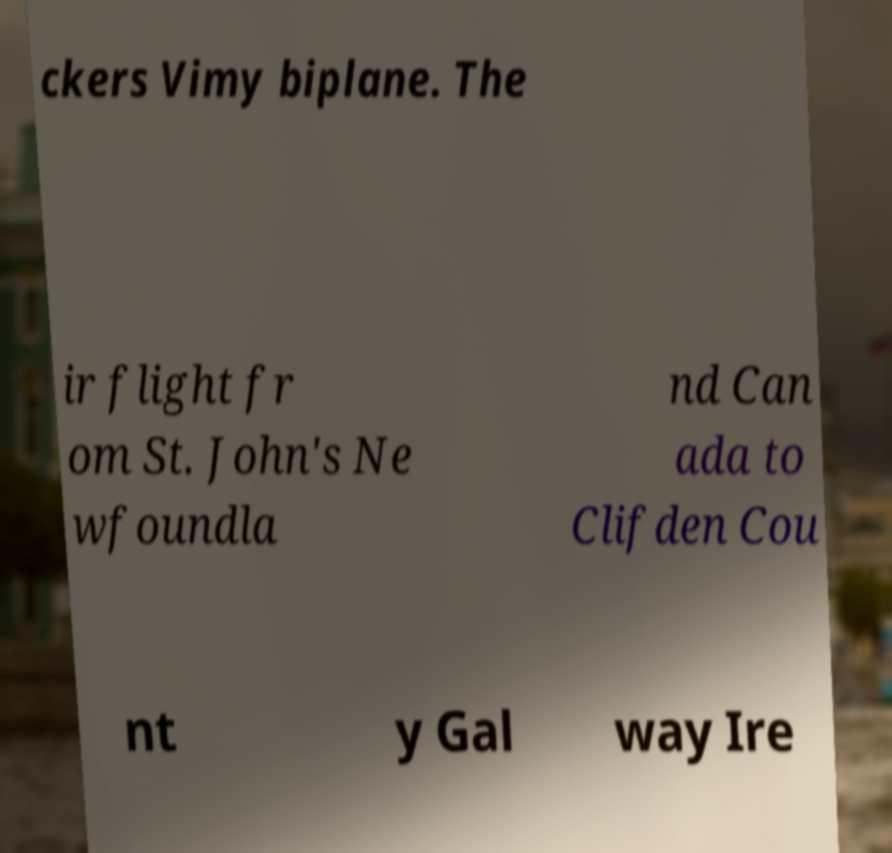There's text embedded in this image that I need extracted. Can you transcribe it verbatim? ckers Vimy biplane. The ir flight fr om St. John's Ne wfoundla nd Can ada to Clifden Cou nt y Gal way Ire 